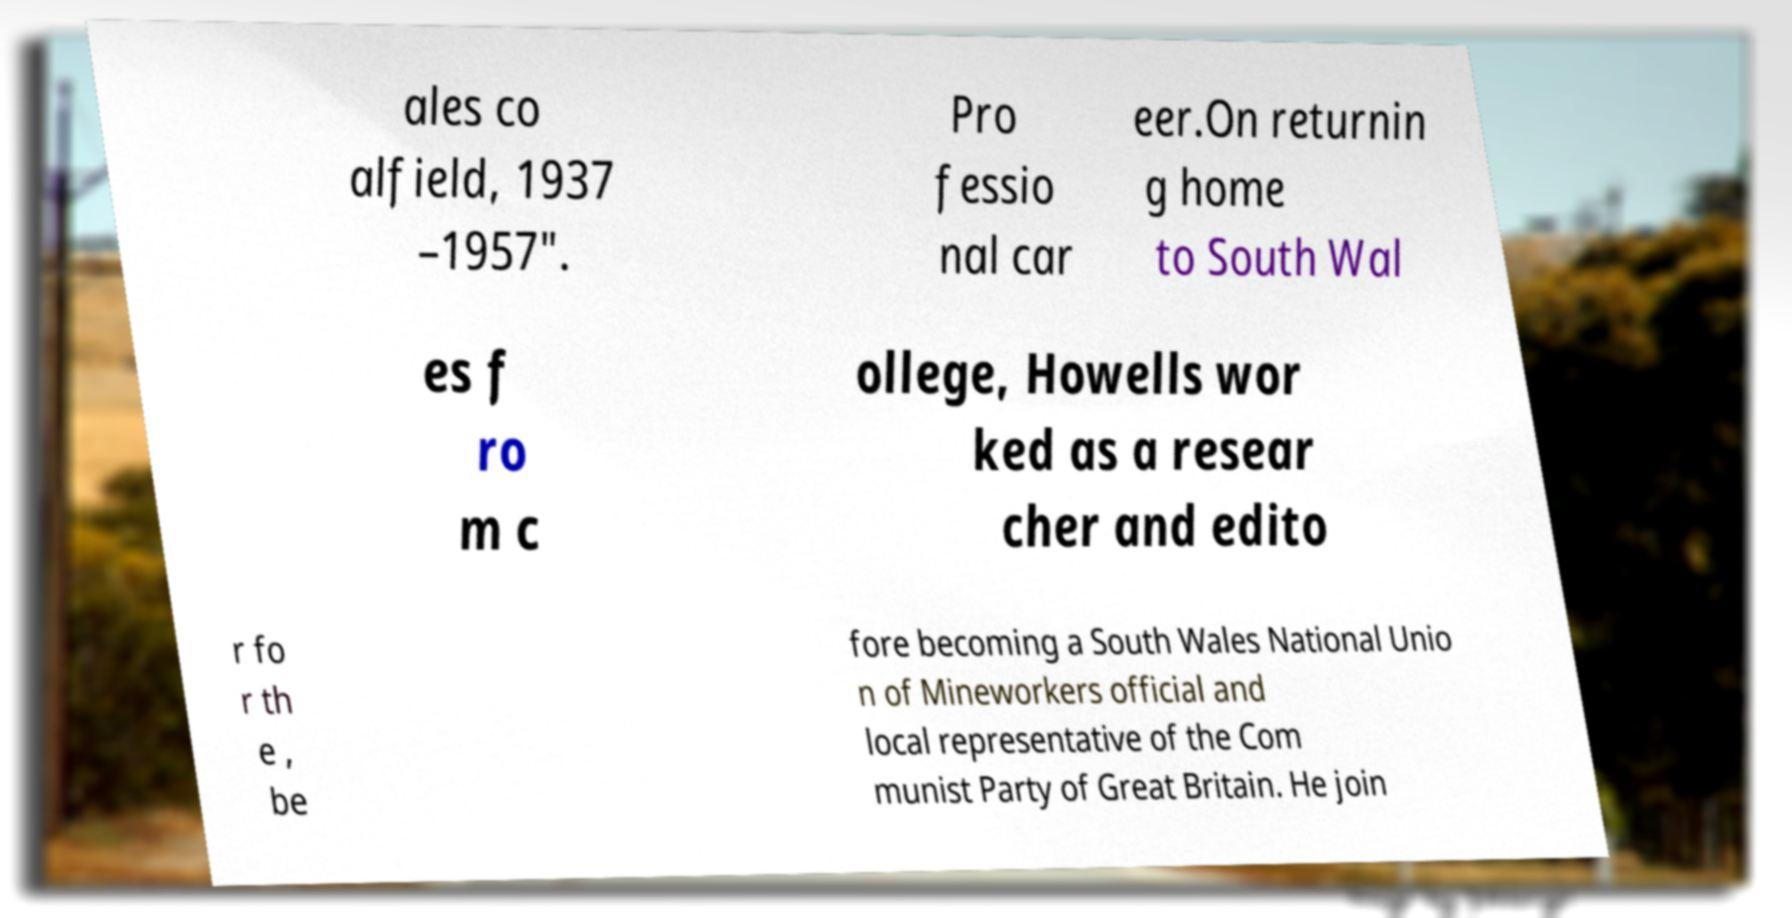Could you assist in decoding the text presented in this image and type it out clearly? ales co alfield, 1937 –1957". Pro fessio nal car eer.On returnin g home to South Wal es f ro m c ollege, Howells wor ked as a resear cher and edito r fo r th e , be fore becoming a South Wales National Unio n of Mineworkers official and local representative of the Com munist Party of Great Britain. He join 